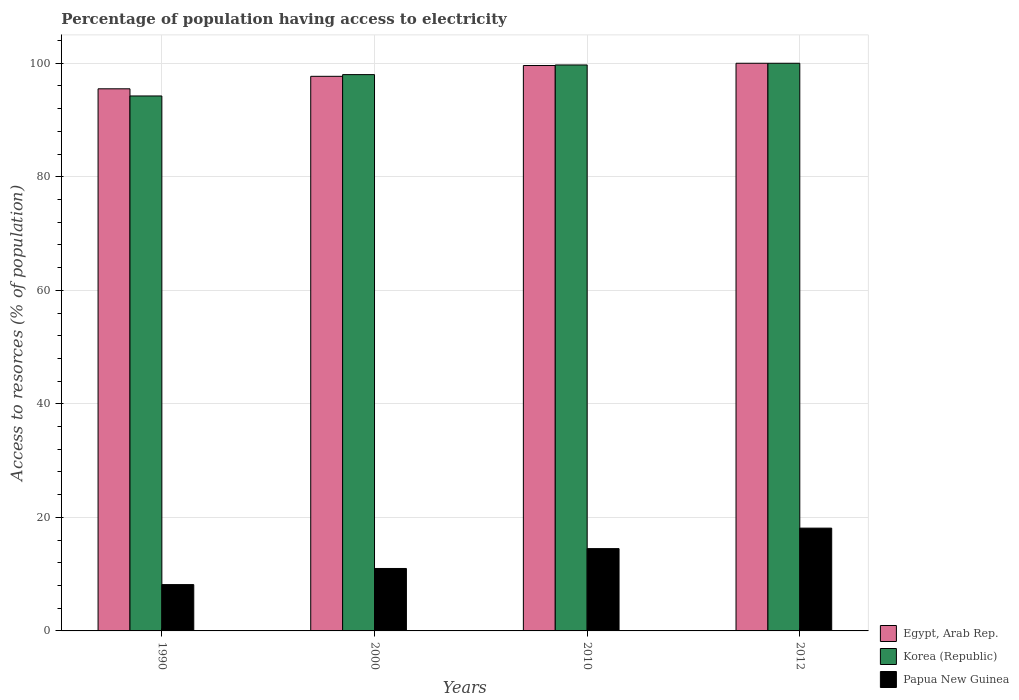How many different coloured bars are there?
Make the answer very short. 3. How many groups of bars are there?
Offer a terse response. 4. Are the number of bars on each tick of the X-axis equal?
Offer a very short reply. Yes. How many bars are there on the 3rd tick from the left?
Keep it short and to the point. 3. What is the label of the 1st group of bars from the left?
Your answer should be very brief. 1990. What is the percentage of population having access to electricity in Papua New Guinea in 2000?
Your answer should be very brief. 11. Across all years, what is the maximum percentage of population having access to electricity in Papua New Guinea?
Provide a succinct answer. 18.11. Across all years, what is the minimum percentage of population having access to electricity in Egypt, Arab Rep.?
Your response must be concise. 95.5. What is the total percentage of population having access to electricity in Egypt, Arab Rep. in the graph?
Make the answer very short. 392.8. What is the difference between the percentage of population having access to electricity in Egypt, Arab Rep. in 1990 and that in 2000?
Offer a very short reply. -2.2. What is the difference between the percentage of population having access to electricity in Egypt, Arab Rep. in 2010 and the percentage of population having access to electricity in Korea (Republic) in 2012?
Ensure brevity in your answer.  -0.4. What is the average percentage of population having access to electricity in Papua New Guinea per year?
Offer a terse response. 12.94. In the year 2012, what is the difference between the percentage of population having access to electricity in Korea (Republic) and percentage of population having access to electricity in Papua New Guinea?
Provide a succinct answer. 81.89. In how many years, is the percentage of population having access to electricity in Papua New Guinea greater than 4 %?
Make the answer very short. 4. What is the ratio of the percentage of population having access to electricity in Papua New Guinea in 1990 to that in 2000?
Your answer should be compact. 0.74. Is the percentage of population having access to electricity in Korea (Republic) in 1990 less than that in 2000?
Keep it short and to the point. Yes. Is the difference between the percentage of population having access to electricity in Korea (Republic) in 2000 and 2010 greater than the difference between the percentage of population having access to electricity in Papua New Guinea in 2000 and 2010?
Ensure brevity in your answer.  Yes. What is the difference between the highest and the second highest percentage of population having access to electricity in Korea (Republic)?
Your answer should be compact. 0.3. What is the difference between the highest and the lowest percentage of population having access to electricity in Korea (Republic)?
Make the answer very short. 5.76. In how many years, is the percentage of population having access to electricity in Egypt, Arab Rep. greater than the average percentage of population having access to electricity in Egypt, Arab Rep. taken over all years?
Provide a short and direct response. 2. What does the 3rd bar from the right in 2012 represents?
Offer a very short reply. Egypt, Arab Rep. How many bars are there?
Give a very brief answer. 12. Are all the bars in the graph horizontal?
Your response must be concise. No. How many years are there in the graph?
Offer a very short reply. 4. What is the difference between two consecutive major ticks on the Y-axis?
Make the answer very short. 20. Does the graph contain any zero values?
Your response must be concise. No. How are the legend labels stacked?
Your response must be concise. Vertical. What is the title of the graph?
Your answer should be compact. Percentage of population having access to electricity. What is the label or title of the Y-axis?
Provide a succinct answer. Access to resorces (% of population). What is the Access to resorces (% of population) of Egypt, Arab Rep. in 1990?
Ensure brevity in your answer.  95.5. What is the Access to resorces (% of population) in Korea (Republic) in 1990?
Offer a very short reply. 94.24. What is the Access to resorces (% of population) in Papua New Guinea in 1990?
Offer a terse response. 8.16. What is the Access to resorces (% of population) of Egypt, Arab Rep. in 2000?
Your response must be concise. 97.7. What is the Access to resorces (% of population) in Korea (Republic) in 2000?
Provide a succinct answer. 98. What is the Access to resorces (% of population) of Papua New Guinea in 2000?
Make the answer very short. 11. What is the Access to resorces (% of population) of Egypt, Arab Rep. in 2010?
Ensure brevity in your answer.  99.6. What is the Access to resorces (% of population) of Korea (Republic) in 2010?
Give a very brief answer. 99.7. What is the Access to resorces (% of population) in Papua New Guinea in 2010?
Keep it short and to the point. 14.5. What is the Access to resorces (% of population) of Papua New Guinea in 2012?
Your response must be concise. 18.11. Across all years, what is the maximum Access to resorces (% of population) in Egypt, Arab Rep.?
Keep it short and to the point. 100. Across all years, what is the maximum Access to resorces (% of population) of Korea (Republic)?
Make the answer very short. 100. Across all years, what is the maximum Access to resorces (% of population) of Papua New Guinea?
Offer a very short reply. 18.11. Across all years, what is the minimum Access to resorces (% of population) of Egypt, Arab Rep.?
Your response must be concise. 95.5. Across all years, what is the minimum Access to resorces (% of population) of Korea (Republic)?
Give a very brief answer. 94.24. Across all years, what is the minimum Access to resorces (% of population) of Papua New Guinea?
Offer a terse response. 8.16. What is the total Access to resorces (% of population) of Egypt, Arab Rep. in the graph?
Offer a very short reply. 392.8. What is the total Access to resorces (% of population) of Korea (Republic) in the graph?
Give a very brief answer. 391.94. What is the total Access to resorces (% of population) in Papua New Guinea in the graph?
Give a very brief answer. 51.77. What is the difference between the Access to resorces (% of population) in Egypt, Arab Rep. in 1990 and that in 2000?
Provide a succinct answer. -2.2. What is the difference between the Access to resorces (% of population) of Korea (Republic) in 1990 and that in 2000?
Your response must be concise. -3.76. What is the difference between the Access to resorces (% of population) of Papua New Guinea in 1990 and that in 2000?
Give a very brief answer. -2.84. What is the difference between the Access to resorces (% of population) of Korea (Republic) in 1990 and that in 2010?
Offer a very short reply. -5.46. What is the difference between the Access to resorces (% of population) of Papua New Guinea in 1990 and that in 2010?
Provide a short and direct response. -6.34. What is the difference between the Access to resorces (% of population) in Korea (Republic) in 1990 and that in 2012?
Your response must be concise. -5.76. What is the difference between the Access to resorces (% of population) of Papua New Guinea in 1990 and that in 2012?
Keep it short and to the point. -9.95. What is the difference between the Access to resorces (% of population) of Egypt, Arab Rep. in 2000 and that in 2012?
Give a very brief answer. -2.3. What is the difference between the Access to resorces (% of population) in Papua New Guinea in 2000 and that in 2012?
Keep it short and to the point. -7.11. What is the difference between the Access to resorces (% of population) of Egypt, Arab Rep. in 2010 and that in 2012?
Your answer should be very brief. -0.4. What is the difference between the Access to resorces (% of population) of Papua New Guinea in 2010 and that in 2012?
Keep it short and to the point. -3.61. What is the difference between the Access to resorces (% of population) in Egypt, Arab Rep. in 1990 and the Access to resorces (% of population) in Korea (Republic) in 2000?
Ensure brevity in your answer.  -2.5. What is the difference between the Access to resorces (% of population) of Egypt, Arab Rep. in 1990 and the Access to resorces (% of population) of Papua New Guinea in 2000?
Offer a very short reply. 84.5. What is the difference between the Access to resorces (% of population) in Korea (Republic) in 1990 and the Access to resorces (% of population) in Papua New Guinea in 2000?
Offer a very short reply. 83.24. What is the difference between the Access to resorces (% of population) in Egypt, Arab Rep. in 1990 and the Access to resorces (% of population) in Korea (Republic) in 2010?
Keep it short and to the point. -4.2. What is the difference between the Access to resorces (% of population) in Korea (Republic) in 1990 and the Access to resorces (% of population) in Papua New Guinea in 2010?
Your answer should be very brief. 79.74. What is the difference between the Access to resorces (% of population) in Egypt, Arab Rep. in 1990 and the Access to resorces (% of population) in Korea (Republic) in 2012?
Your answer should be very brief. -4.5. What is the difference between the Access to resorces (% of population) in Egypt, Arab Rep. in 1990 and the Access to resorces (% of population) in Papua New Guinea in 2012?
Provide a short and direct response. 77.39. What is the difference between the Access to resorces (% of population) of Korea (Republic) in 1990 and the Access to resorces (% of population) of Papua New Guinea in 2012?
Provide a succinct answer. 76.13. What is the difference between the Access to resorces (% of population) in Egypt, Arab Rep. in 2000 and the Access to resorces (% of population) in Korea (Republic) in 2010?
Your answer should be compact. -2. What is the difference between the Access to resorces (% of population) of Egypt, Arab Rep. in 2000 and the Access to resorces (% of population) of Papua New Guinea in 2010?
Provide a succinct answer. 83.2. What is the difference between the Access to resorces (% of population) in Korea (Republic) in 2000 and the Access to resorces (% of population) in Papua New Guinea in 2010?
Provide a short and direct response. 83.5. What is the difference between the Access to resorces (% of population) in Egypt, Arab Rep. in 2000 and the Access to resorces (% of population) in Korea (Republic) in 2012?
Keep it short and to the point. -2.3. What is the difference between the Access to resorces (% of population) in Egypt, Arab Rep. in 2000 and the Access to resorces (% of population) in Papua New Guinea in 2012?
Ensure brevity in your answer.  79.59. What is the difference between the Access to resorces (% of population) in Korea (Republic) in 2000 and the Access to resorces (% of population) in Papua New Guinea in 2012?
Provide a succinct answer. 79.89. What is the difference between the Access to resorces (% of population) of Egypt, Arab Rep. in 2010 and the Access to resorces (% of population) of Korea (Republic) in 2012?
Provide a succinct answer. -0.4. What is the difference between the Access to resorces (% of population) of Egypt, Arab Rep. in 2010 and the Access to resorces (% of population) of Papua New Guinea in 2012?
Give a very brief answer. 81.49. What is the difference between the Access to resorces (% of population) of Korea (Republic) in 2010 and the Access to resorces (% of population) of Papua New Guinea in 2012?
Ensure brevity in your answer.  81.59. What is the average Access to resorces (% of population) of Egypt, Arab Rep. per year?
Keep it short and to the point. 98.2. What is the average Access to resorces (% of population) in Korea (Republic) per year?
Provide a succinct answer. 97.98. What is the average Access to resorces (% of population) in Papua New Guinea per year?
Offer a terse response. 12.94. In the year 1990, what is the difference between the Access to resorces (% of population) in Egypt, Arab Rep. and Access to resorces (% of population) in Korea (Republic)?
Your answer should be compact. 1.26. In the year 1990, what is the difference between the Access to resorces (% of population) of Egypt, Arab Rep. and Access to resorces (% of population) of Papua New Guinea?
Your answer should be very brief. 87.34. In the year 1990, what is the difference between the Access to resorces (% of population) of Korea (Republic) and Access to resorces (% of population) of Papua New Guinea?
Your answer should be very brief. 86.08. In the year 2000, what is the difference between the Access to resorces (% of population) in Egypt, Arab Rep. and Access to resorces (% of population) in Papua New Guinea?
Provide a succinct answer. 86.7. In the year 2000, what is the difference between the Access to resorces (% of population) of Korea (Republic) and Access to resorces (% of population) of Papua New Guinea?
Your answer should be compact. 87. In the year 2010, what is the difference between the Access to resorces (% of population) in Egypt, Arab Rep. and Access to resorces (% of population) in Papua New Guinea?
Ensure brevity in your answer.  85.1. In the year 2010, what is the difference between the Access to resorces (% of population) of Korea (Republic) and Access to resorces (% of population) of Papua New Guinea?
Ensure brevity in your answer.  85.2. In the year 2012, what is the difference between the Access to resorces (% of population) in Egypt, Arab Rep. and Access to resorces (% of population) in Korea (Republic)?
Ensure brevity in your answer.  0. In the year 2012, what is the difference between the Access to resorces (% of population) of Egypt, Arab Rep. and Access to resorces (% of population) of Papua New Guinea?
Offer a very short reply. 81.89. In the year 2012, what is the difference between the Access to resorces (% of population) of Korea (Republic) and Access to resorces (% of population) of Papua New Guinea?
Provide a succinct answer. 81.89. What is the ratio of the Access to resorces (% of population) in Egypt, Arab Rep. in 1990 to that in 2000?
Your answer should be very brief. 0.98. What is the ratio of the Access to resorces (% of population) in Korea (Republic) in 1990 to that in 2000?
Ensure brevity in your answer.  0.96. What is the ratio of the Access to resorces (% of population) in Papua New Guinea in 1990 to that in 2000?
Your answer should be very brief. 0.74. What is the ratio of the Access to resorces (% of population) of Egypt, Arab Rep. in 1990 to that in 2010?
Offer a very short reply. 0.96. What is the ratio of the Access to resorces (% of population) of Korea (Republic) in 1990 to that in 2010?
Your answer should be compact. 0.95. What is the ratio of the Access to resorces (% of population) in Papua New Guinea in 1990 to that in 2010?
Your answer should be compact. 0.56. What is the ratio of the Access to resorces (% of population) of Egypt, Arab Rep. in 1990 to that in 2012?
Keep it short and to the point. 0.95. What is the ratio of the Access to resorces (% of population) in Korea (Republic) in 1990 to that in 2012?
Your response must be concise. 0.94. What is the ratio of the Access to resorces (% of population) of Papua New Guinea in 1990 to that in 2012?
Keep it short and to the point. 0.45. What is the ratio of the Access to resorces (% of population) of Egypt, Arab Rep. in 2000 to that in 2010?
Your answer should be compact. 0.98. What is the ratio of the Access to resorces (% of population) in Korea (Republic) in 2000 to that in 2010?
Your answer should be compact. 0.98. What is the ratio of the Access to resorces (% of population) of Papua New Guinea in 2000 to that in 2010?
Your answer should be compact. 0.76. What is the ratio of the Access to resorces (% of population) of Papua New Guinea in 2000 to that in 2012?
Give a very brief answer. 0.61. What is the ratio of the Access to resorces (% of population) in Papua New Guinea in 2010 to that in 2012?
Keep it short and to the point. 0.8. What is the difference between the highest and the second highest Access to resorces (% of population) of Egypt, Arab Rep.?
Provide a short and direct response. 0.4. What is the difference between the highest and the second highest Access to resorces (% of population) in Papua New Guinea?
Offer a terse response. 3.61. What is the difference between the highest and the lowest Access to resorces (% of population) in Egypt, Arab Rep.?
Make the answer very short. 4.5. What is the difference between the highest and the lowest Access to resorces (% of population) in Korea (Republic)?
Your response must be concise. 5.76. What is the difference between the highest and the lowest Access to resorces (% of population) of Papua New Guinea?
Give a very brief answer. 9.95. 